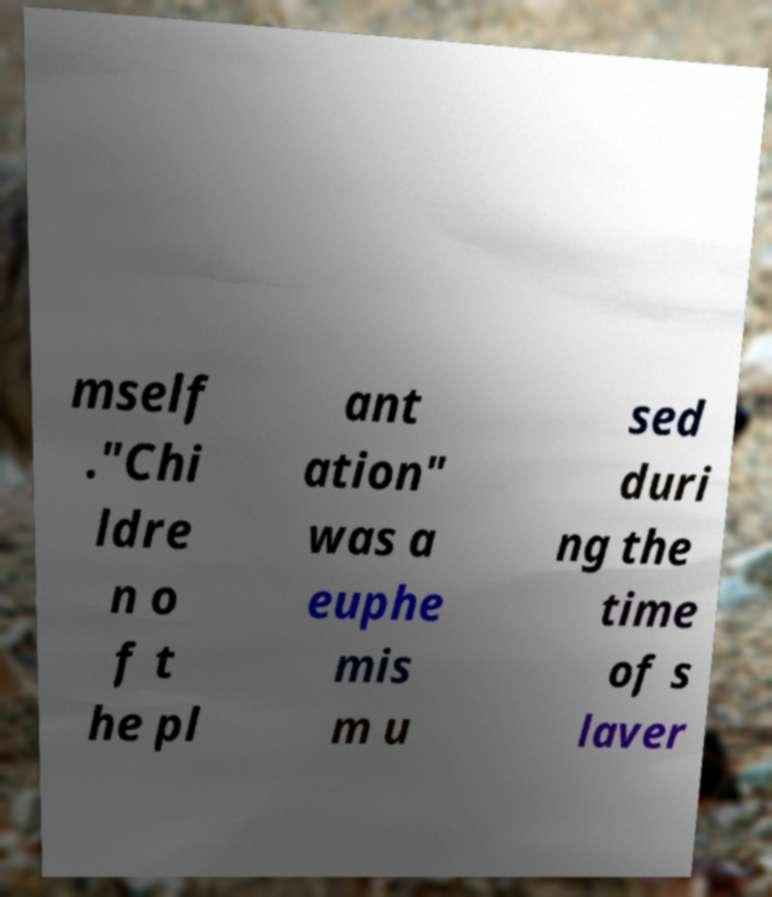What messages or text are displayed in this image? I need them in a readable, typed format. mself ."Chi ldre n o f t he pl ant ation" was a euphe mis m u sed duri ng the time of s laver 